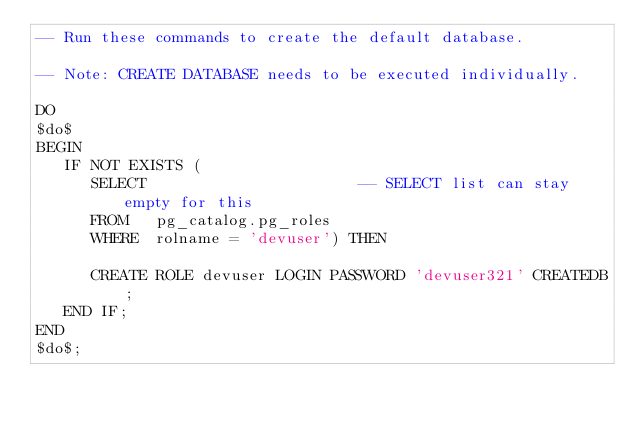<code> <loc_0><loc_0><loc_500><loc_500><_SQL_>-- Run these commands to create the default database.

-- Note: CREATE DATABASE needs to be executed individually.

DO
$do$
BEGIN
   IF NOT EXISTS (
      SELECT                       -- SELECT list can stay empty for this
      FROM   pg_catalog.pg_roles
      WHERE  rolname = 'devuser') THEN

      CREATE ROLE devuser LOGIN PASSWORD 'devuser321' CREATEDB;
   END IF;
END
$do$;

</code> 